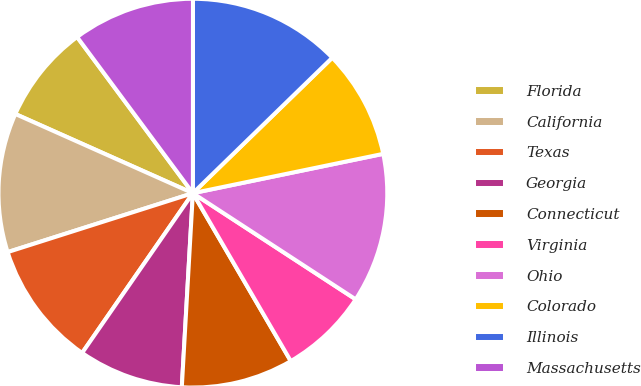Convert chart. <chart><loc_0><loc_0><loc_500><loc_500><pie_chart><fcel>Florida<fcel>California<fcel>Texas<fcel>Georgia<fcel>Connecticut<fcel>Virginia<fcel>Ohio<fcel>Colorado<fcel>Illinois<fcel>Massachusetts<nl><fcel>8.17%<fcel>11.58%<fcel>10.45%<fcel>8.74%<fcel>9.31%<fcel>7.4%<fcel>12.44%<fcel>9.03%<fcel>12.72%<fcel>10.16%<nl></chart> 